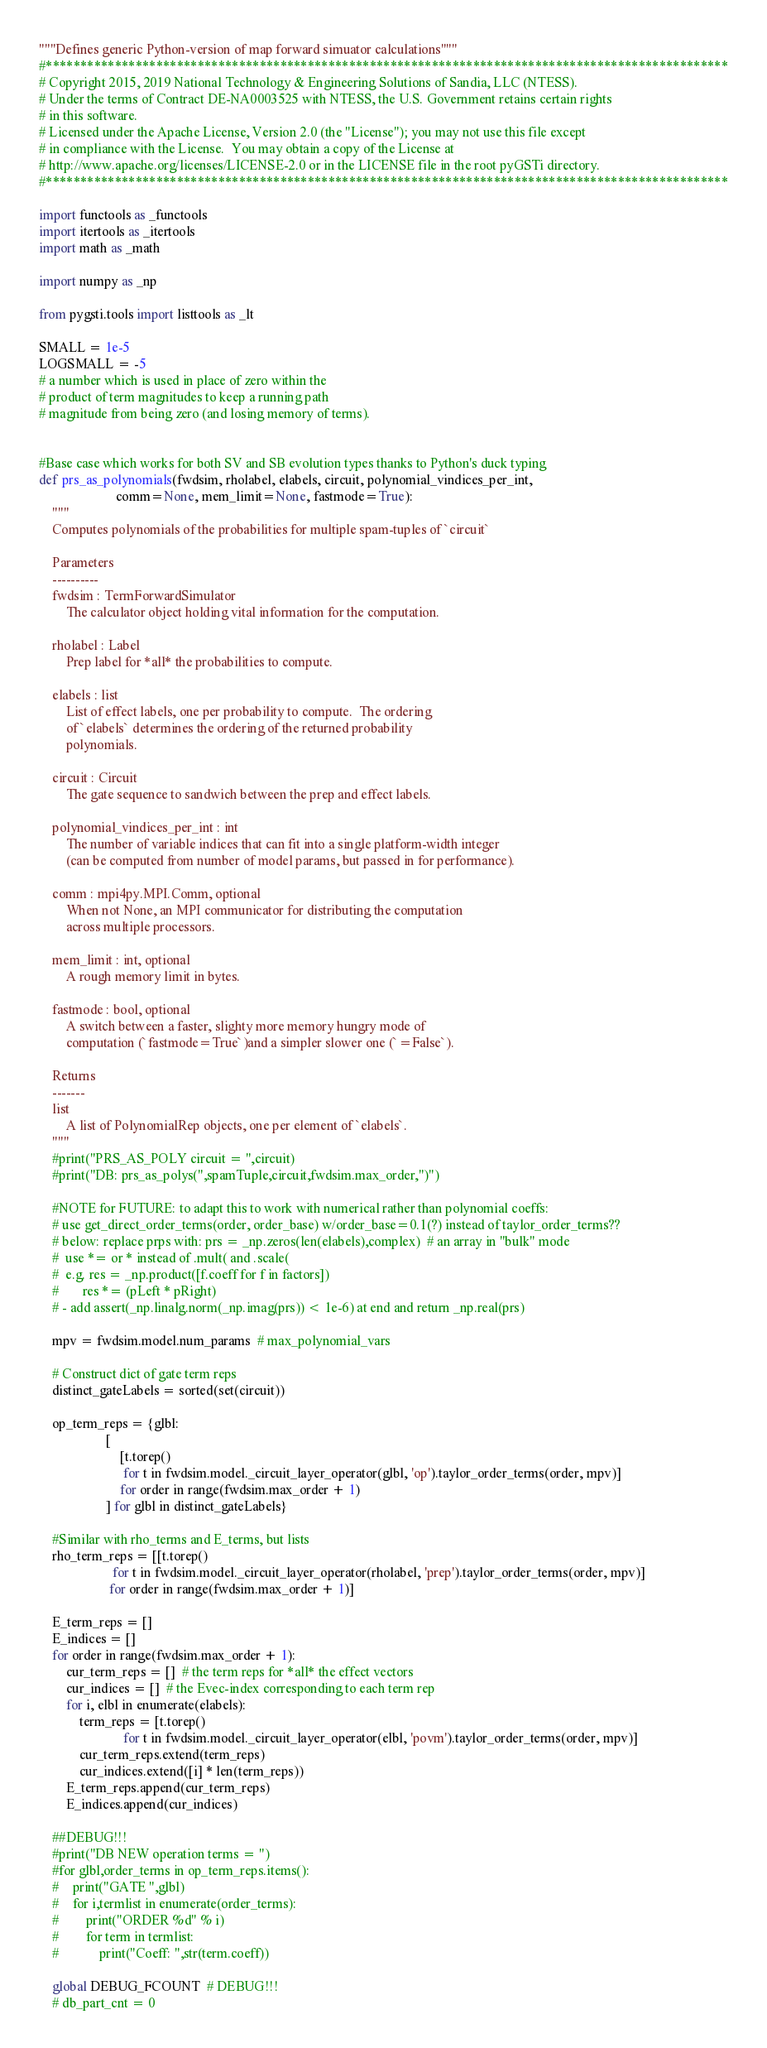Convert code to text. <code><loc_0><loc_0><loc_500><loc_500><_Python_>"""Defines generic Python-version of map forward simuator calculations"""
#***************************************************************************************************
# Copyright 2015, 2019 National Technology & Engineering Solutions of Sandia, LLC (NTESS).
# Under the terms of Contract DE-NA0003525 with NTESS, the U.S. Government retains certain rights
# in this software.
# Licensed under the Apache License, Version 2.0 (the "License"); you may not use this file except
# in compliance with the License.  You may obtain a copy of the License at
# http://www.apache.org/licenses/LICENSE-2.0 or in the LICENSE file in the root pyGSTi directory.
#***************************************************************************************************

import functools as _functools
import itertools as _itertools
import math as _math

import numpy as _np

from pygsti.tools import listtools as _lt

SMALL = 1e-5
LOGSMALL = -5
# a number which is used in place of zero within the
# product of term magnitudes to keep a running path
# magnitude from being zero (and losing memory of terms).


#Base case which works for both SV and SB evolution types thanks to Python's duck typing
def prs_as_polynomials(fwdsim, rholabel, elabels, circuit, polynomial_vindices_per_int,
                       comm=None, mem_limit=None, fastmode=True):
    """
    Computes polynomials of the probabilities for multiple spam-tuples of `circuit`

    Parameters
    ----------
    fwdsim : TermForwardSimulator
        The calculator object holding vital information for the computation.

    rholabel : Label
        Prep label for *all* the probabilities to compute.

    elabels : list
        List of effect labels, one per probability to compute.  The ordering
        of `elabels` determines the ordering of the returned probability
        polynomials.

    circuit : Circuit
        The gate sequence to sandwich between the prep and effect labels.

    polynomial_vindices_per_int : int
        The number of variable indices that can fit into a single platform-width integer
        (can be computed from number of model params, but passed in for performance).

    comm : mpi4py.MPI.Comm, optional
        When not None, an MPI communicator for distributing the computation
        across multiple processors.

    mem_limit : int, optional
        A rough memory limit in bytes.

    fastmode : bool, optional
        A switch between a faster, slighty more memory hungry mode of
        computation (`fastmode=True`)and a simpler slower one (`=False`).

    Returns
    -------
    list
        A list of PolynomialRep objects, one per element of `elabels`.
    """
    #print("PRS_AS_POLY circuit = ",circuit)
    #print("DB: prs_as_polys(",spamTuple,circuit,fwdsim.max_order,")")

    #NOTE for FUTURE: to adapt this to work with numerical rather than polynomial coeffs:
    # use get_direct_order_terms(order, order_base) w/order_base=0.1(?) instead of taylor_order_terms??
    # below: replace prps with: prs = _np.zeros(len(elabels),complex)  # an array in "bulk" mode
    #  use *= or * instead of .mult( and .scale(
    #  e.g. res = _np.product([f.coeff for f in factors])
    #       res *= (pLeft * pRight)
    # - add assert(_np.linalg.norm(_np.imag(prs)) < 1e-6) at end and return _np.real(prs)

    mpv = fwdsim.model.num_params  # max_polynomial_vars

    # Construct dict of gate term reps
    distinct_gateLabels = sorted(set(circuit))

    op_term_reps = {glbl:
                    [
                        [t.torep()
                         for t in fwdsim.model._circuit_layer_operator(glbl, 'op').taylor_order_terms(order, mpv)]
                        for order in range(fwdsim.max_order + 1)
                    ] for glbl in distinct_gateLabels}

    #Similar with rho_terms and E_terms, but lists
    rho_term_reps = [[t.torep()
                      for t in fwdsim.model._circuit_layer_operator(rholabel, 'prep').taylor_order_terms(order, mpv)]
                     for order in range(fwdsim.max_order + 1)]

    E_term_reps = []
    E_indices = []
    for order in range(fwdsim.max_order + 1):
        cur_term_reps = []  # the term reps for *all* the effect vectors
        cur_indices = []  # the Evec-index corresponding to each term rep
        for i, elbl in enumerate(elabels):
            term_reps = [t.torep()
                         for t in fwdsim.model._circuit_layer_operator(elbl, 'povm').taylor_order_terms(order, mpv)]
            cur_term_reps.extend(term_reps)
            cur_indices.extend([i] * len(term_reps))
        E_term_reps.append(cur_term_reps)
        E_indices.append(cur_indices)

    ##DEBUG!!!
    #print("DB NEW operation terms = ")
    #for glbl,order_terms in op_term_reps.items():
    #    print("GATE ",glbl)
    #    for i,termlist in enumerate(order_terms):
    #        print("ORDER %d" % i)
    #        for term in termlist:
    #            print("Coeff: ",str(term.coeff))

    global DEBUG_FCOUNT  # DEBUG!!!
    # db_part_cnt = 0</code> 